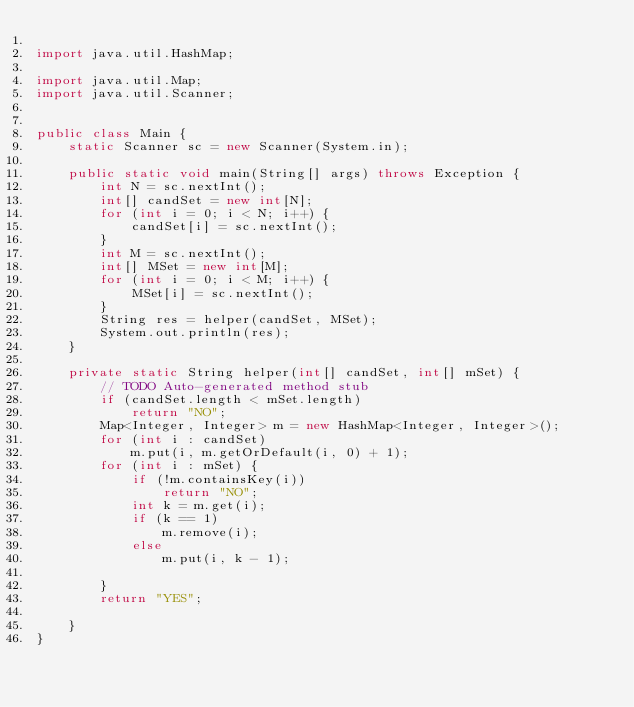Convert code to text. <code><loc_0><loc_0><loc_500><loc_500><_Java_>
import java.util.HashMap;

import java.util.Map;
import java.util.Scanner;


public class Main {
	static Scanner sc = new Scanner(System.in);

	public static void main(String[] args) throws Exception {
		int N = sc.nextInt();
		int[] candSet = new int[N];
		for (int i = 0; i < N; i++) {
			candSet[i] = sc.nextInt();
		}
		int M = sc.nextInt();
		int[] MSet = new int[M];
		for (int i = 0; i < M; i++) {
			MSet[i] = sc.nextInt();
		}
		String res = helper(candSet, MSet);
		System.out.println(res);
	}

	private static String helper(int[] candSet, int[] mSet) {
		// TODO Auto-generated method stub
		if (candSet.length < mSet.length)
			return "NO";
		Map<Integer, Integer> m = new HashMap<Integer, Integer>();
		for (int i : candSet)
			m.put(i, m.getOrDefault(i, 0) + 1);
		for (int i : mSet) {
			if (!m.containsKey(i))
				return "NO";
			int k = m.get(i);
			if (k == 1)
				m.remove(i);
			else
				m.put(i, k - 1);

		}
		return "YES";

	}
}</code> 